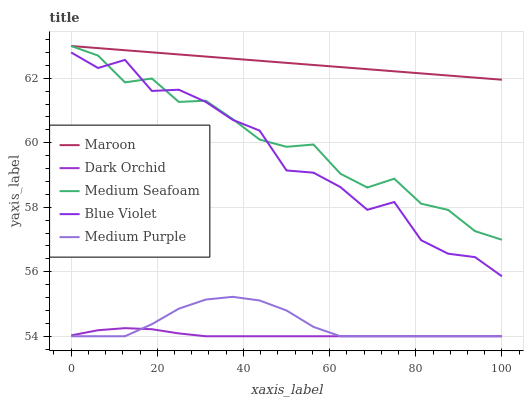Does Dark Orchid have the minimum area under the curve?
Answer yes or no. Yes. Does Maroon have the maximum area under the curve?
Answer yes or no. Yes. Does Medium Purple have the minimum area under the curve?
Answer yes or no. No. Does Medium Purple have the maximum area under the curve?
Answer yes or no. No. Is Maroon the smoothest?
Answer yes or no. Yes. Is Blue Violet the roughest?
Answer yes or no. Yes. Is Medium Purple the smoothest?
Answer yes or no. No. Is Medium Purple the roughest?
Answer yes or no. No. Does Maroon have the lowest value?
Answer yes or no. No. Does Medium Seafoam have the highest value?
Answer yes or no. Yes. Does Medium Purple have the highest value?
Answer yes or no. No. Is Medium Purple less than Blue Violet?
Answer yes or no. Yes. Is Maroon greater than Blue Violet?
Answer yes or no. Yes. Does Maroon intersect Medium Seafoam?
Answer yes or no. Yes. Is Maroon less than Medium Seafoam?
Answer yes or no. No. Is Maroon greater than Medium Seafoam?
Answer yes or no. No. Does Medium Purple intersect Blue Violet?
Answer yes or no. No. 